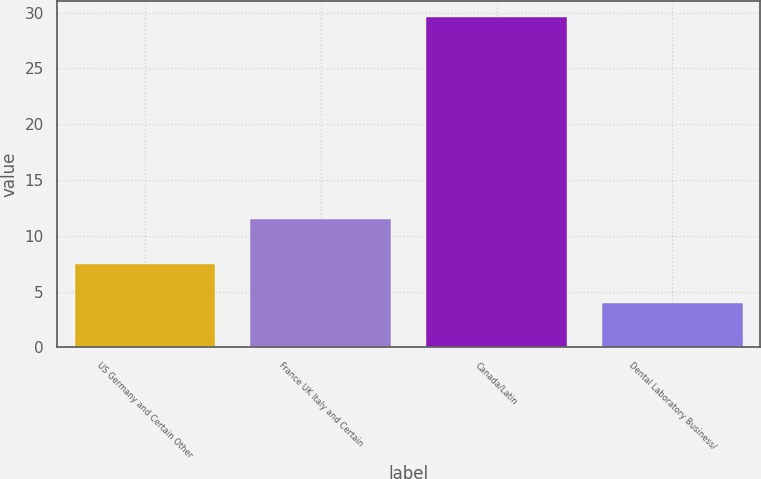Convert chart. <chart><loc_0><loc_0><loc_500><loc_500><bar_chart><fcel>US Germany and Certain Other<fcel>France UK Italy and Certain<fcel>Canada/Latin<fcel>Dental Laboratory Business/<nl><fcel>7.5<fcel>11.5<fcel>29.6<fcel>4<nl></chart> 